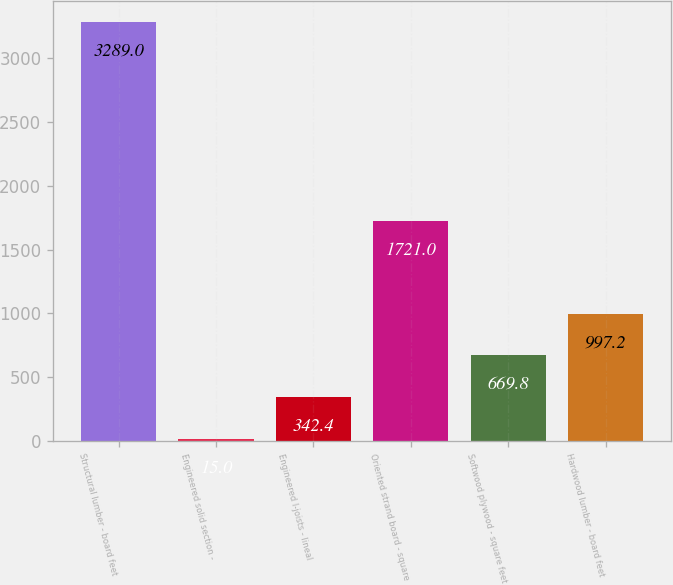Convert chart. <chart><loc_0><loc_0><loc_500><loc_500><bar_chart><fcel>Structural lumber - board feet<fcel>Engineered solid section -<fcel>Engineered I-joists - lineal<fcel>Oriented strand board - square<fcel>Softwood plywood - square feet<fcel>Hardwood lumber - board feet<nl><fcel>3289<fcel>15<fcel>342.4<fcel>1721<fcel>669.8<fcel>997.2<nl></chart> 